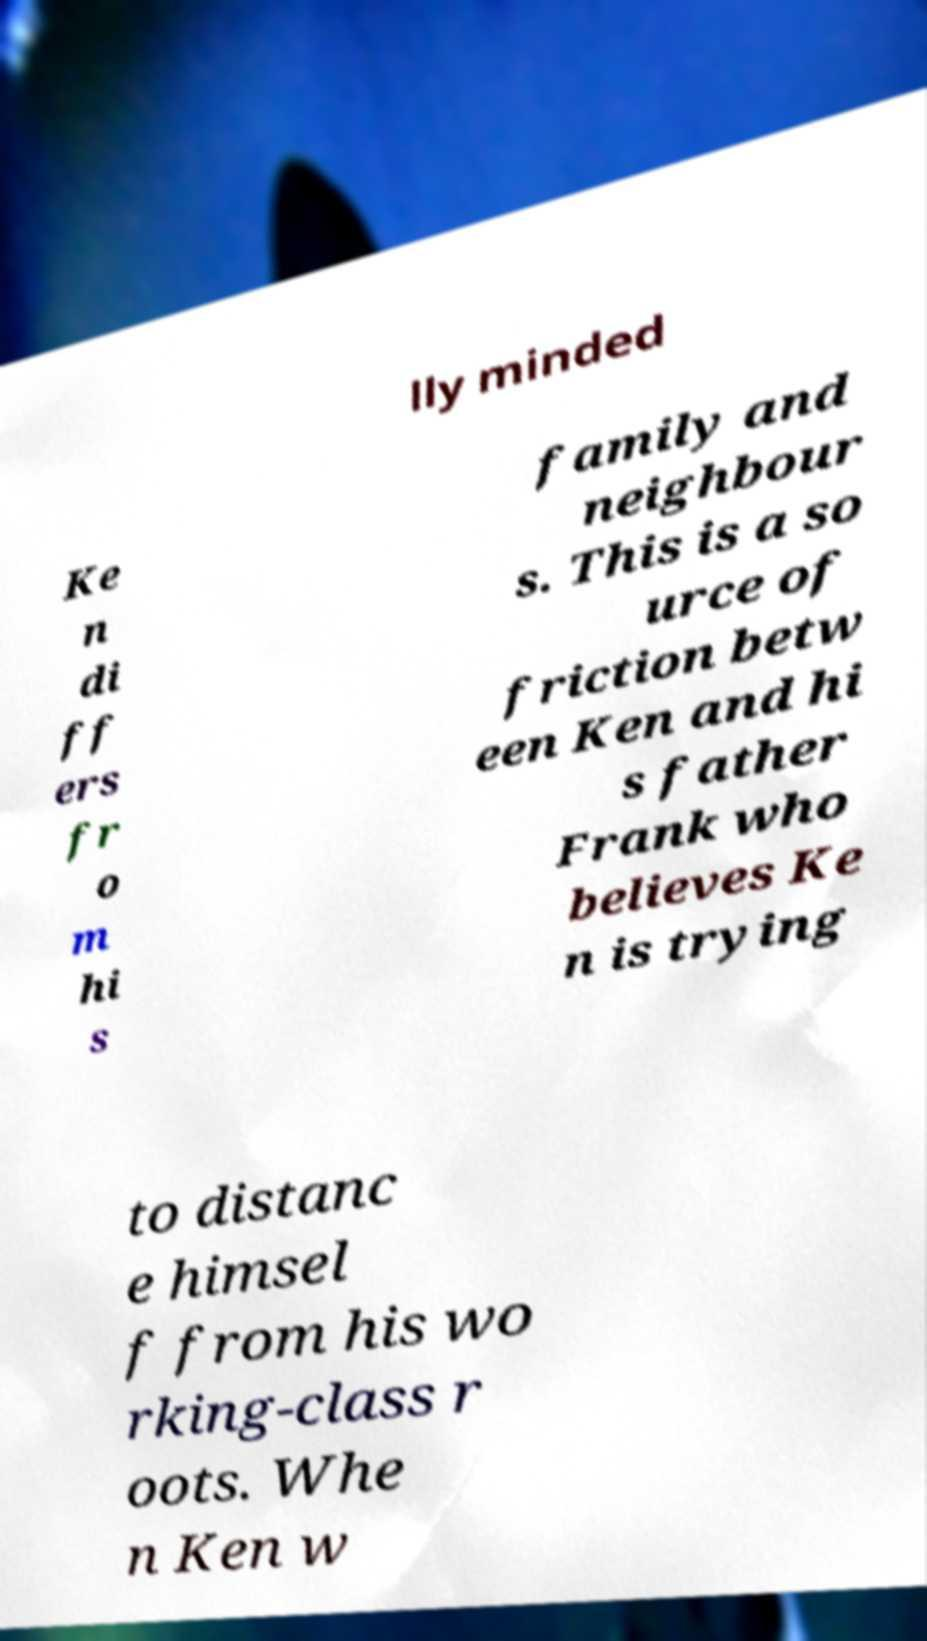Please read and relay the text visible in this image. What does it say? lly minded Ke n di ff ers fr o m hi s family and neighbour s. This is a so urce of friction betw een Ken and hi s father Frank who believes Ke n is trying to distanc e himsel f from his wo rking-class r oots. Whe n Ken w 